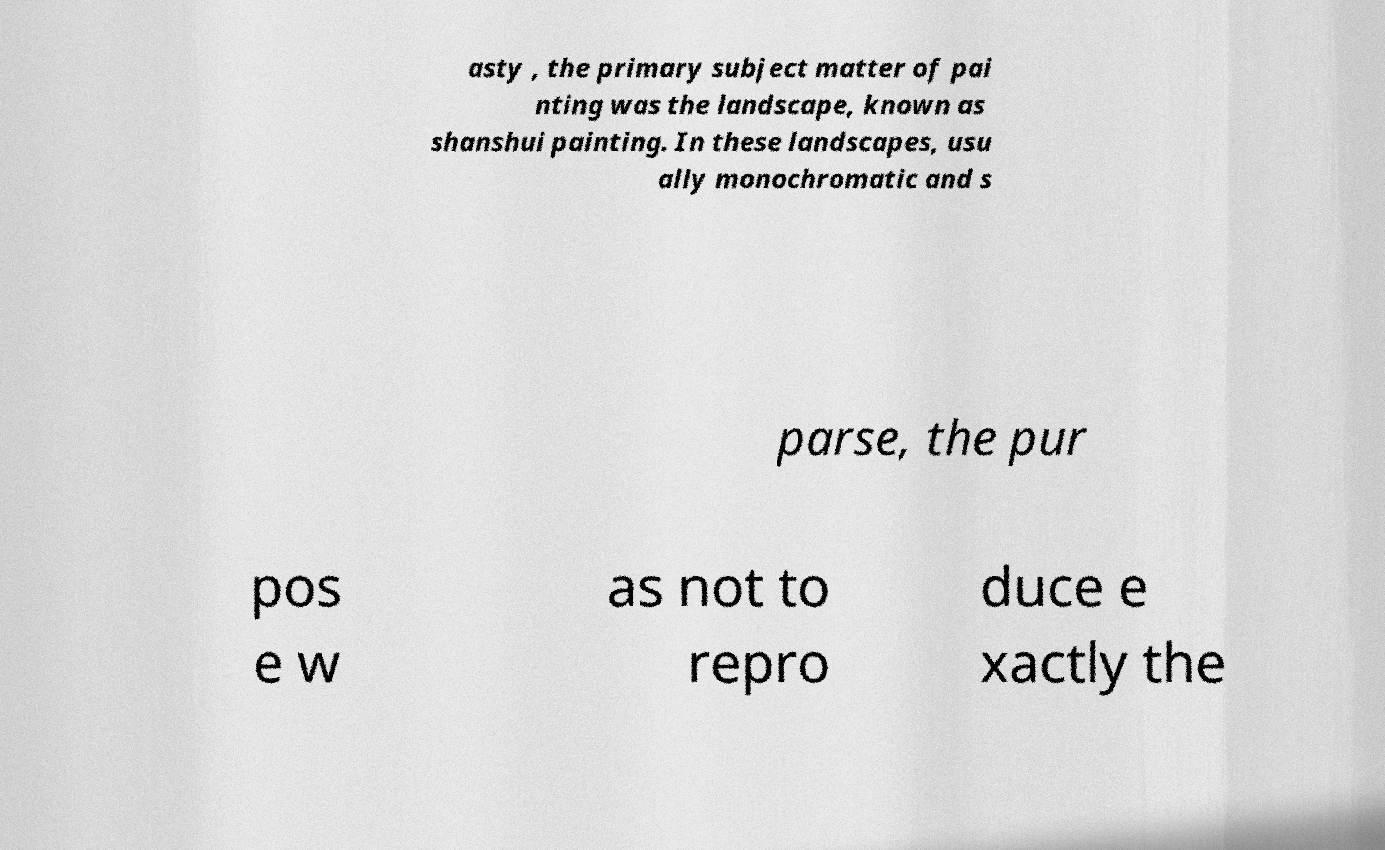Could you extract and type out the text from this image? asty , the primary subject matter of pai nting was the landscape, known as shanshui painting. In these landscapes, usu ally monochromatic and s parse, the pur pos e w as not to repro duce e xactly the 